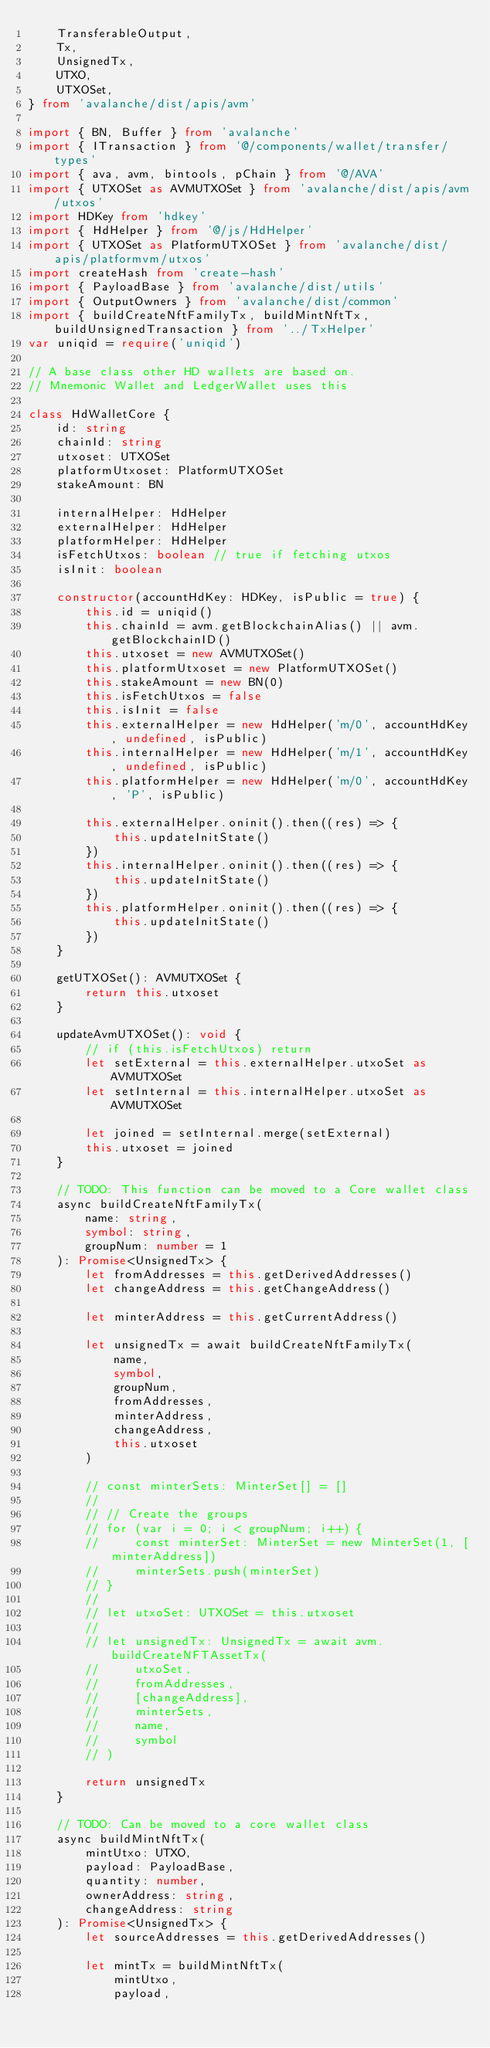Convert code to text. <code><loc_0><loc_0><loc_500><loc_500><_TypeScript_>    TransferableOutput,
    Tx,
    UnsignedTx,
    UTXO,
    UTXOSet,
} from 'avalanche/dist/apis/avm'

import { BN, Buffer } from 'avalanche'
import { ITransaction } from '@/components/wallet/transfer/types'
import { ava, avm, bintools, pChain } from '@/AVA'
import { UTXOSet as AVMUTXOSet } from 'avalanche/dist/apis/avm/utxos'
import HDKey from 'hdkey'
import { HdHelper } from '@/js/HdHelper'
import { UTXOSet as PlatformUTXOSet } from 'avalanche/dist/apis/platformvm/utxos'
import createHash from 'create-hash'
import { PayloadBase } from 'avalanche/dist/utils'
import { OutputOwners } from 'avalanche/dist/common'
import { buildCreateNftFamilyTx, buildMintNftTx, buildUnsignedTransaction } from '../TxHelper'
var uniqid = require('uniqid')

// A base class other HD wallets are based on.
// Mnemonic Wallet and LedgerWallet uses this

class HdWalletCore {
    id: string
    chainId: string
    utxoset: UTXOSet
    platformUtxoset: PlatformUTXOSet
    stakeAmount: BN

    internalHelper: HdHelper
    externalHelper: HdHelper
    platformHelper: HdHelper
    isFetchUtxos: boolean // true if fetching utxos
    isInit: boolean

    constructor(accountHdKey: HDKey, isPublic = true) {
        this.id = uniqid()
        this.chainId = avm.getBlockchainAlias() || avm.getBlockchainID()
        this.utxoset = new AVMUTXOSet()
        this.platformUtxoset = new PlatformUTXOSet()
        this.stakeAmount = new BN(0)
        this.isFetchUtxos = false
        this.isInit = false
        this.externalHelper = new HdHelper('m/0', accountHdKey, undefined, isPublic)
        this.internalHelper = new HdHelper('m/1', accountHdKey, undefined, isPublic)
        this.platformHelper = new HdHelper('m/0', accountHdKey, 'P', isPublic)

        this.externalHelper.oninit().then((res) => {
            this.updateInitState()
        })
        this.internalHelper.oninit().then((res) => {
            this.updateInitState()
        })
        this.platformHelper.oninit().then((res) => {
            this.updateInitState()
        })
    }

    getUTXOSet(): AVMUTXOSet {
        return this.utxoset
    }

    updateAvmUTXOSet(): void {
        // if (this.isFetchUtxos) return
        let setExternal = this.externalHelper.utxoSet as AVMUTXOSet
        let setInternal = this.internalHelper.utxoSet as AVMUTXOSet

        let joined = setInternal.merge(setExternal)
        this.utxoset = joined
    }

    // TODO: This function can be moved to a Core wallet class
    async buildCreateNftFamilyTx(
        name: string,
        symbol: string,
        groupNum: number = 1
    ): Promise<UnsignedTx> {
        let fromAddresses = this.getDerivedAddresses()
        let changeAddress = this.getChangeAddress()

        let minterAddress = this.getCurrentAddress()

        let unsignedTx = await buildCreateNftFamilyTx(
            name,
            symbol,
            groupNum,
            fromAddresses,
            minterAddress,
            changeAddress,
            this.utxoset
        )

        // const minterSets: MinterSet[] = []
        //
        // // Create the groups
        // for (var i = 0; i < groupNum; i++) {
        //     const minterSet: MinterSet = new MinterSet(1, [minterAddress])
        //     minterSets.push(minterSet)
        // }
        //
        // let utxoSet: UTXOSet = this.utxoset
        //
        // let unsignedTx: UnsignedTx = await avm.buildCreateNFTAssetTx(
        //     utxoSet,
        //     fromAddresses,
        //     [changeAddress],
        //     minterSets,
        //     name,
        //     symbol
        // )

        return unsignedTx
    }

    // TODO: Can be moved to a core wallet class
    async buildMintNftTx(
        mintUtxo: UTXO,
        payload: PayloadBase,
        quantity: number,
        ownerAddress: string,
        changeAddress: string
    ): Promise<UnsignedTx> {
        let sourceAddresses = this.getDerivedAddresses()

        let mintTx = buildMintNftTx(
            mintUtxo,
            payload,</code> 